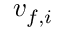Convert formula to latex. <formula><loc_0><loc_0><loc_500><loc_500>v _ { f , i }</formula> 